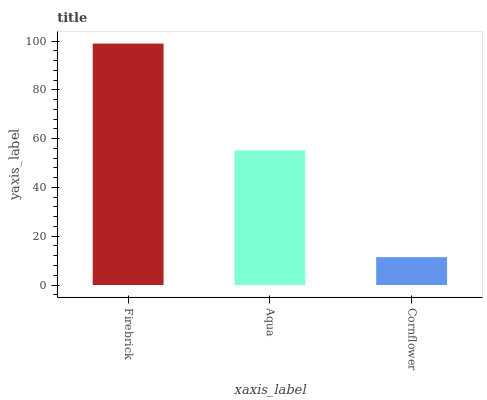Is Cornflower the minimum?
Answer yes or no. Yes. Is Firebrick the maximum?
Answer yes or no. Yes. Is Aqua the minimum?
Answer yes or no. No. Is Aqua the maximum?
Answer yes or no. No. Is Firebrick greater than Aqua?
Answer yes or no. Yes. Is Aqua less than Firebrick?
Answer yes or no. Yes. Is Aqua greater than Firebrick?
Answer yes or no. No. Is Firebrick less than Aqua?
Answer yes or no. No. Is Aqua the high median?
Answer yes or no. Yes. Is Aqua the low median?
Answer yes or no. Yes. Is Firebrick the high median?
Answer yes or no. No. Is Firebrick the low median?
Answer yes or no. No. 